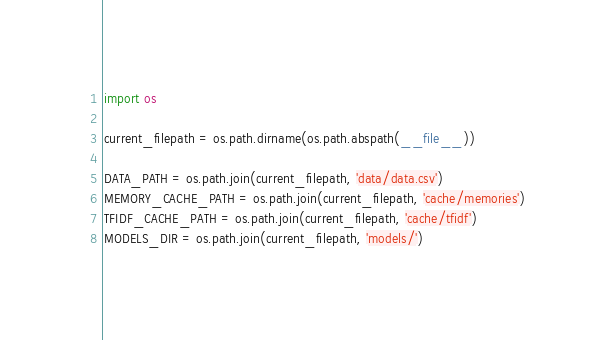Convert code to text. <code><loc_0><loc_0><loc_500><loc_500><_Python_>import os

current_filepath = os.path.dirname(os.path.abspath(__file__))

DATA_PATH = os.path.join(current_filepath, 'data/data.csv')
MEMORY_CACHE_PATH = os.path.join(current_filepath, 'cache/memories')
TFIDF_CACHE_PATH = os.path.join(current_filepath, 'cache/tfidf')
MODELS_DIR = os.path.join(current_filepath, 'models/')
</code> 